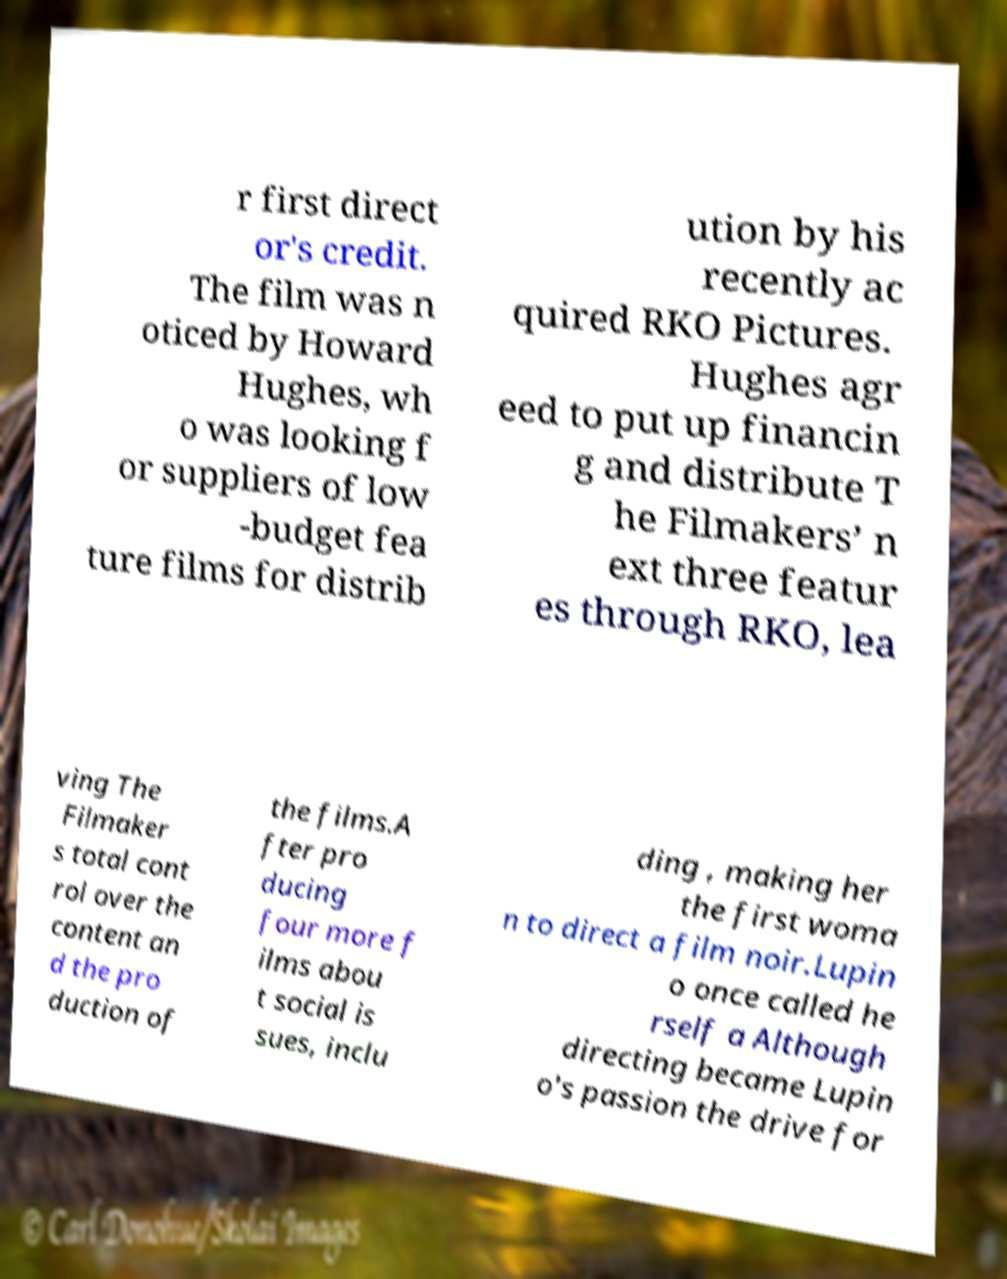Can you accurately transcribe the text from the provided image for me? r first direct or's credit. The film was n oticed by Howard Hughes, wh o was looking f or suppliers of low -budget fea ture films for distrib ution by his recently ac quired RKO Pictures. Hughes agr eed to put up financin g and distribute T he Filmakers’ n ext three featur es through RKO, lea ving The Filmaker s total cont rol over the content an d the pro duction of the films.A fter pro ducing four more f ilms abou t social is sues, inclu ding , making her the first woma n to direct a film noir.Lupin o once called he rself a Although directing became Lupin o's passion the drive for 